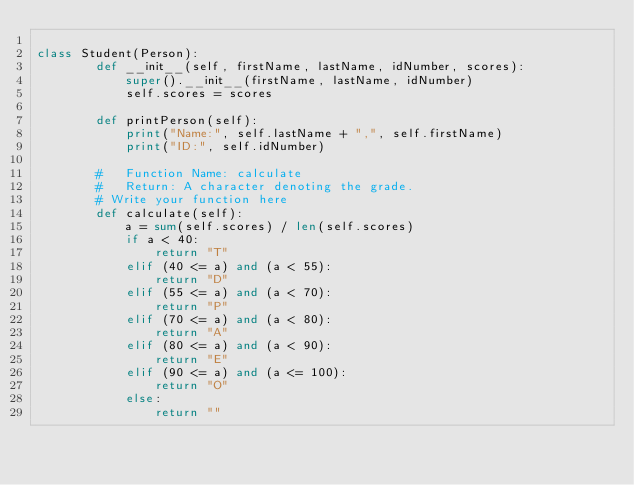Convert code to text. <code><loc_0><loc_0><loc_500><loc_500><_Python_>
class Student(Person):
        def __init__(self, firstName, lastName, idNumber, scores):
            super().__init__(firstName, lastName, idNumber)
            self.scores = scores

        def printPerson(self):
            print("Name:", self.lastName + ",", self.firstName)
            print("ID:", self.idNumber)

        #   Function Name: calculate
        #   Return: A character denoting the grade.
        # Write your function here
        def calculate(self):
            a = sum(self.scores) / len(self.scores)
            if a < 40:
                return "T"
            elif (40 <= a) and (a < 55):
                return "D"
            elif (55 <= a) and (a < 70):
                return "P"
            elif (70 <= a) and (a < 80):
                return "A"
            elif (80 <= a) and (a < 90):
                return "E"
            elif (90 <= a) and (a <= 100):
                return "O"
            else:
                return ""
</code> 